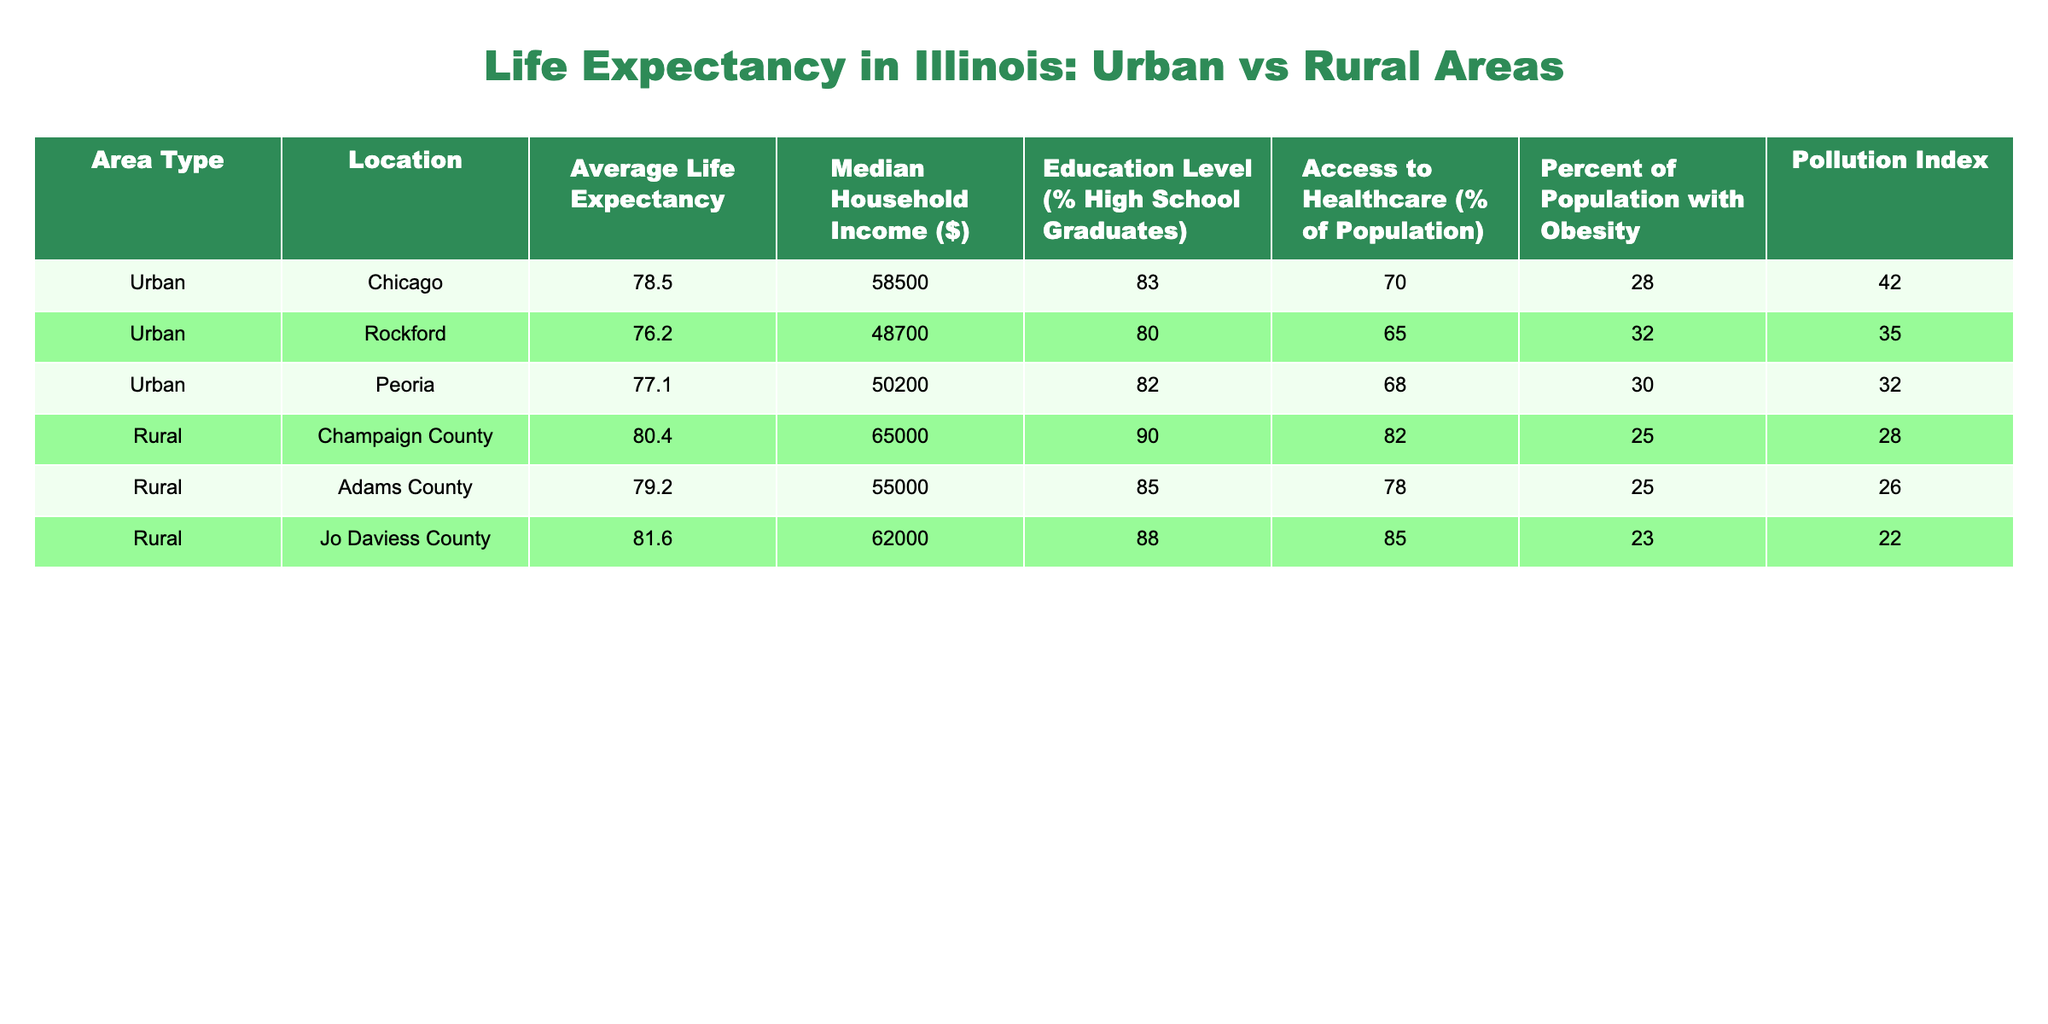What is the average life expectancy for urban areas in Illinois? To find the average life expectancy for urban areas, I look at the life expectancy values for Chicago, Rockford, and Peoria. Those values are 78.5, 76.2, and 77.1 years. Adding them gives 231.8, and dividing by the number of urban areas (3) results in an average of 231.8 / 3 = 77.27 years.
Answer: 77.27 years What is the highest median household income among the areas listed? I need to compare the median household income values across all areas. The values are 58500 for Chicago, 48700 for Rockford, 50200 for Peoria, 65000 for Champaign County, 55000 for Adams County, and 62000 for Jo Daviess County. The highest value is 65000 from Champaign County.
Answer: 65000 Does Jo Daviess County have a higher average life expectancy than Chicago? I compare the average life expectancy of Jo Daviess County, which is 81.6 years, with Chicago's life expectancy of 78.5 years. Since 81.6 is greater than 78.5, the statement is true.
Answer: Yes What is the pollution index for the area with the lowest access to healthcare? I find the access to healthcare percentages: Chicago has 70%, Rockford 65%, Peoria 68%, Champaign County 82%, Adams County 78%, and Jo Daviess County 85%. The area with the lowest access is Rockford at 65%, which has a pollution index of 35.
Answer: 35 How much higher is the average life expectancy in rural areas compared to urban areas? I first calculate the average life expectancy for rural areas: Champaign County (80.4), Adams County (79.2), and Jo Daviess County (81.6) yield a total of 241.2, divided by 3 gives an average of 80.4 years. The urban average is previously calculated as 77.27 years. The difference is 80.4 - 77.27 = 3.13 years.
Answer: 3.13 years Is the obesity rate higher in urban or rural areas? I compare the obesity percentages: Urban areas have 28% (Chicago), 32% (Rockford), and 30% (Peoria). The average is (28 + 32 + 30) / 3 = 30%. Rural areas have 25% (Champaign County), 25% (Adams County), and 23% (Jo Daviess County), with an average of (25 + 25 + 23) / 3 = 24.33%. Since 30% is greater than 24.33%, urban areas have a higher obesity rate.
Answer: Yes What is the median household income for Jo Daviess County? Looking at the table, Jo Daviess County's median household income is listed directly as 62000. There's no additional calculation needed.
Answer: 62000 Which area has the highest access to healthcare and what is its value? I examine the access to healthcare percentages: Chicago 70%, Rockford 65%, Peoria 68%, Champaign County 82%, Adams County 78%, and Jo Daviess County 85%. Jo Daviess County has the highest percentage at 85%.
Answer: Jo Daviess County, 85% 